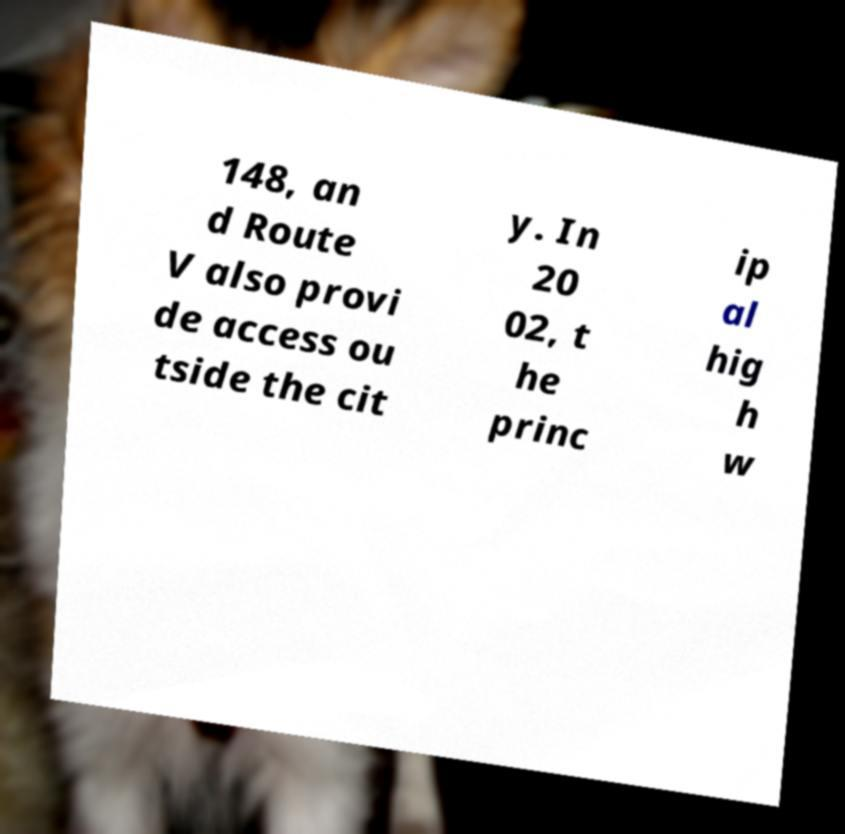There's text embedded in this image that I need extracted. Can you transcribe it verbatim? 148, an d Route V also provi de access ou tside the cit y. In 20 02, t he princ ip al hig h w 